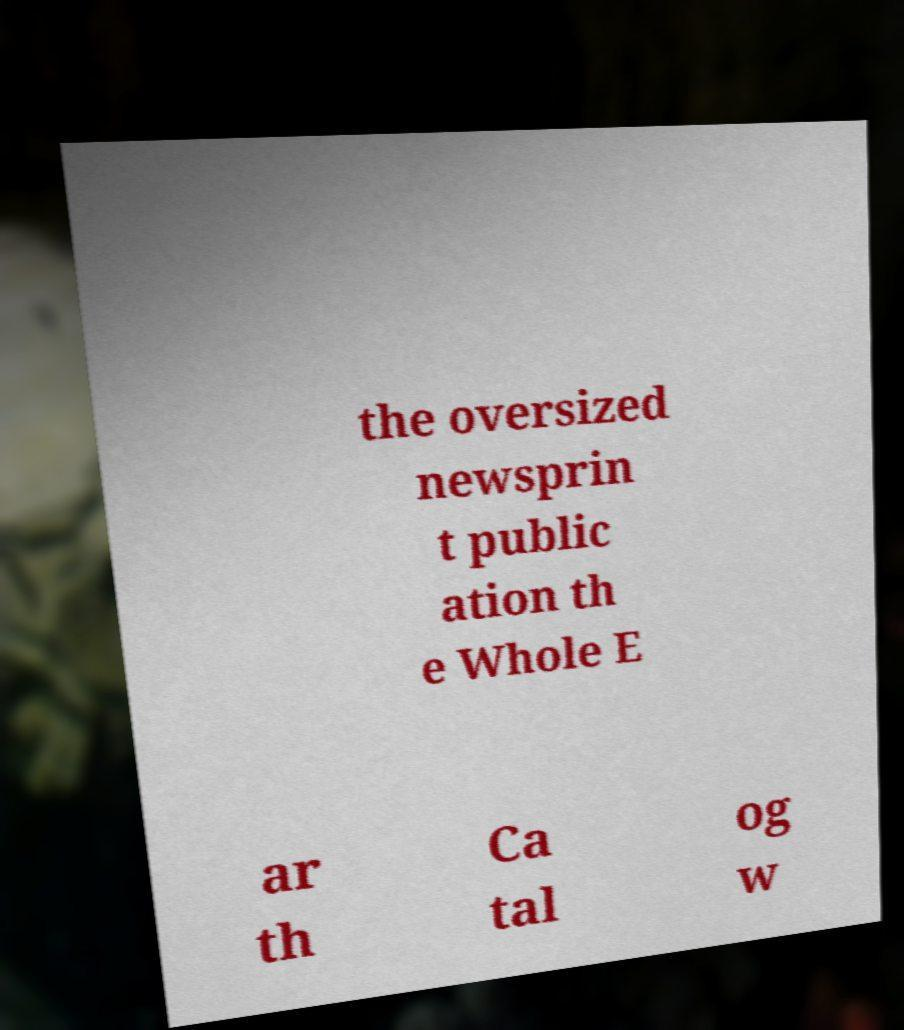I need the written content from this picture converted into text. Can you do that? the oversized newsprin t public ation th e Whole E ar th Ca tal og w 